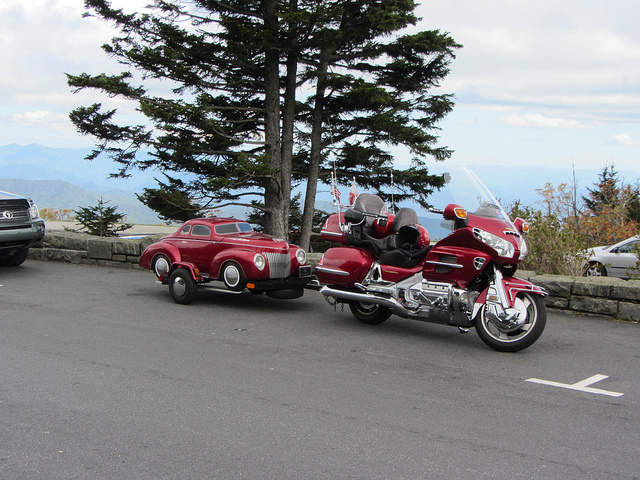How many tusks does the elephant on the left have? Actually, the image does not contain any elephants. Instead, it features a motorcycle and a small red car parked next to a tree with a beautiful mountainous landscape in the background. 